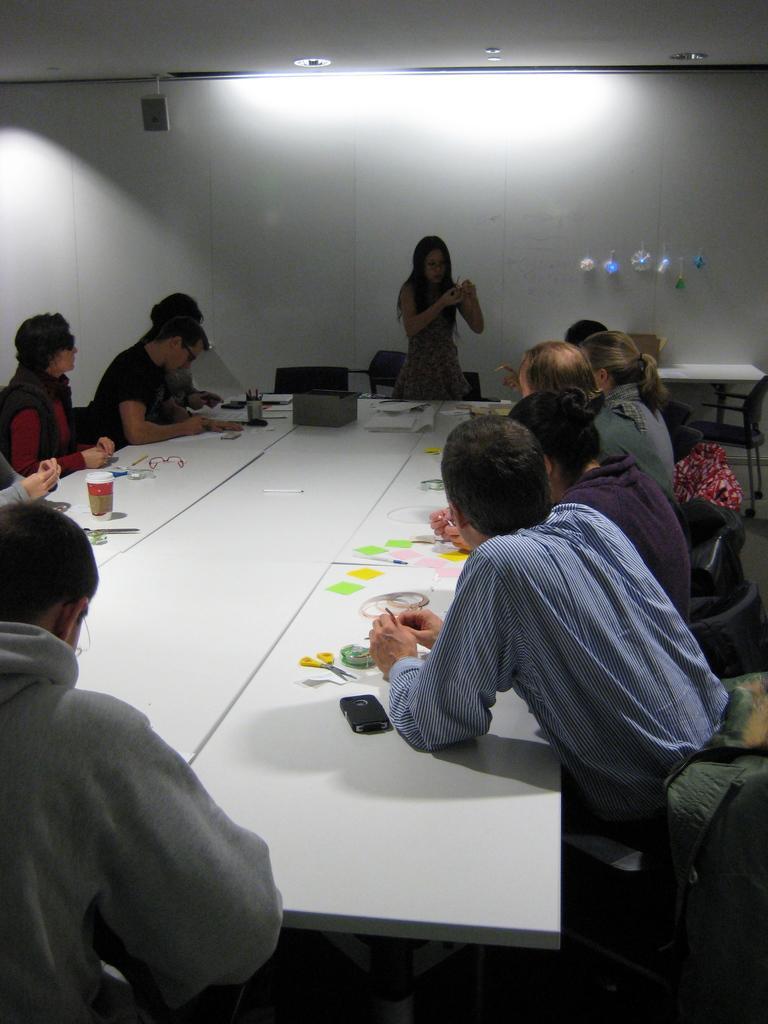Could you give a brief overview of what you see in this image? In this picture we can see some persons sitting on chair and in front of them there is table and on table we can see glass, spectacle, pens, pen stand,box, papers and here woman standing and talking to them and in background we can see wall, lights. 